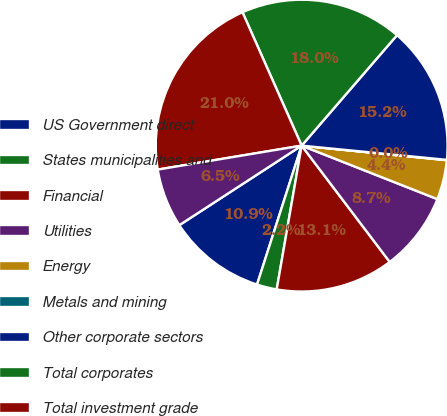Convert chart to OTSL. <chart><loc_0><loc_0><loc_500><loc_500><pie_chart><fcel>US Government direct<fcel>States municipalities and<fcel>Financial<fcel>Utilities<fcel>Energy<fcel>Metals and mining<fcel>Other corporate sectors<fcel>Total corporates<fcel>Total investment grade<fcel>Total below investment grade<nl><fcel>10.88%<fcel>2.21%<fcel>13.05%<fcel>8.71%<fcel>4.38%<fcel>0.04%<fcel>15.22%<fcel>17.98%<fcel>20.98%<fcel>6.55%<nl></chart> 